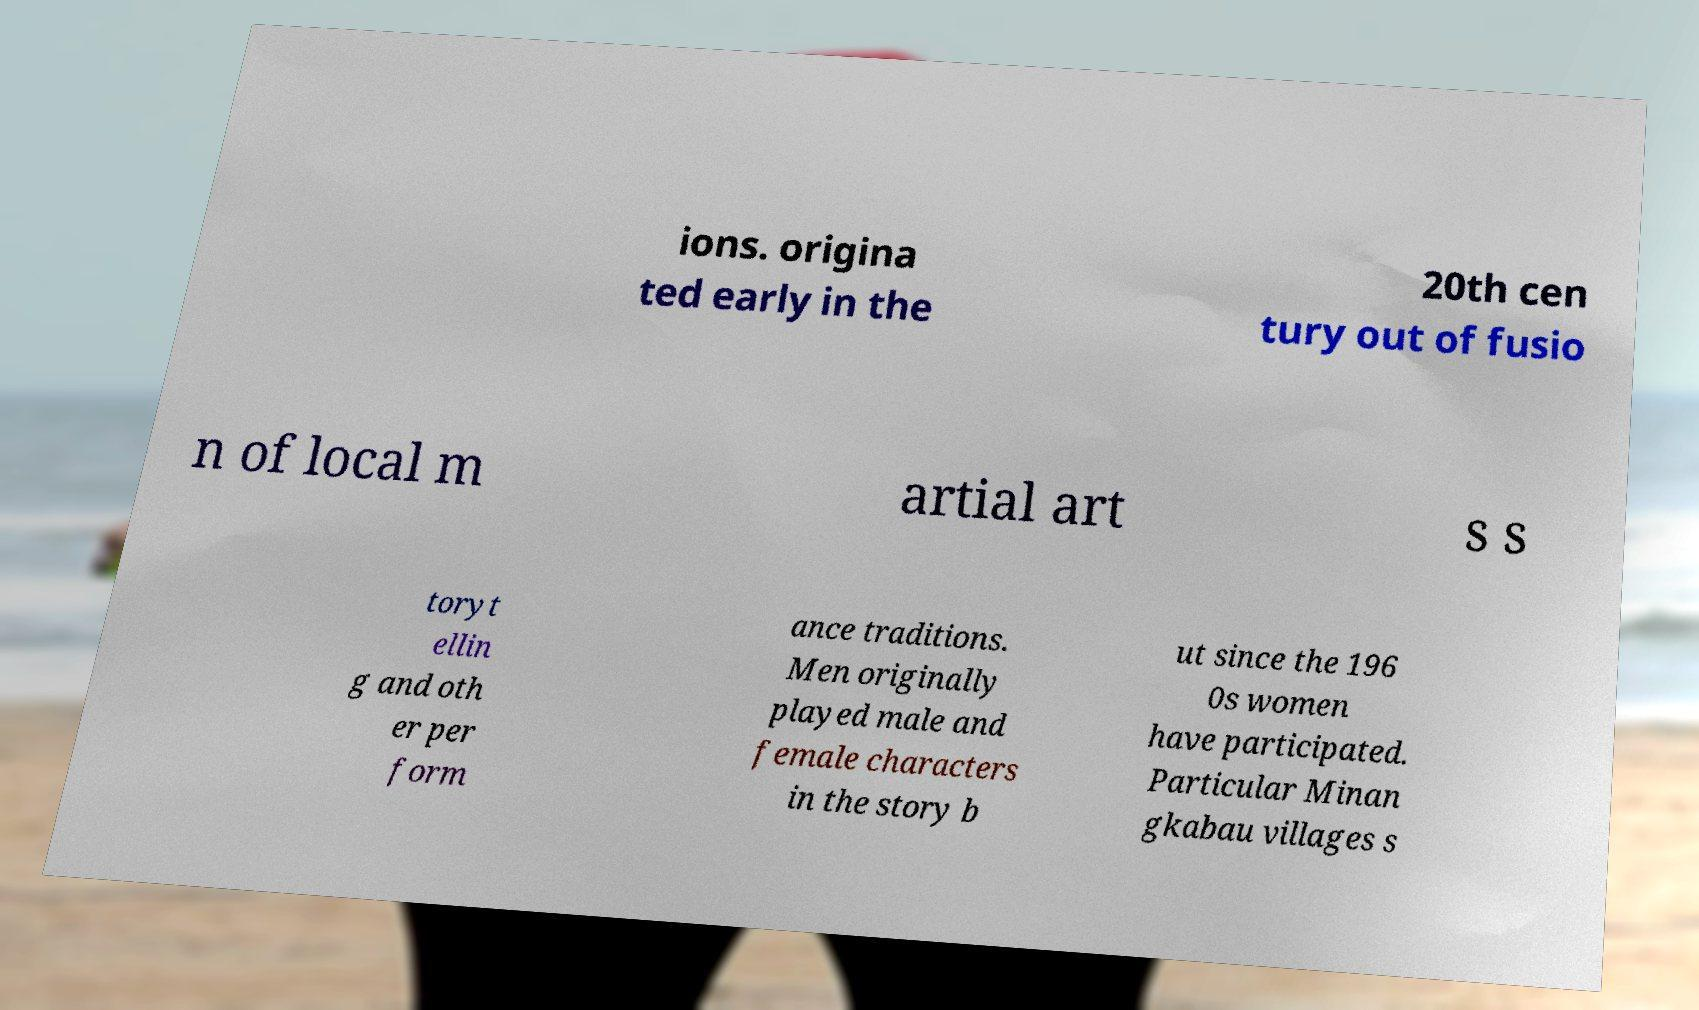Could you assist in decoding the text presented in this image and type it out clearly? ions. origina ted early in the 20th cen tury out of fusio n of local m artial art s s toryt ellin g and oth er per form ance traditions. Men originally played male and female characters in the story b ut since the 196 0s women have participated. Particular Minan gkabau villages s 